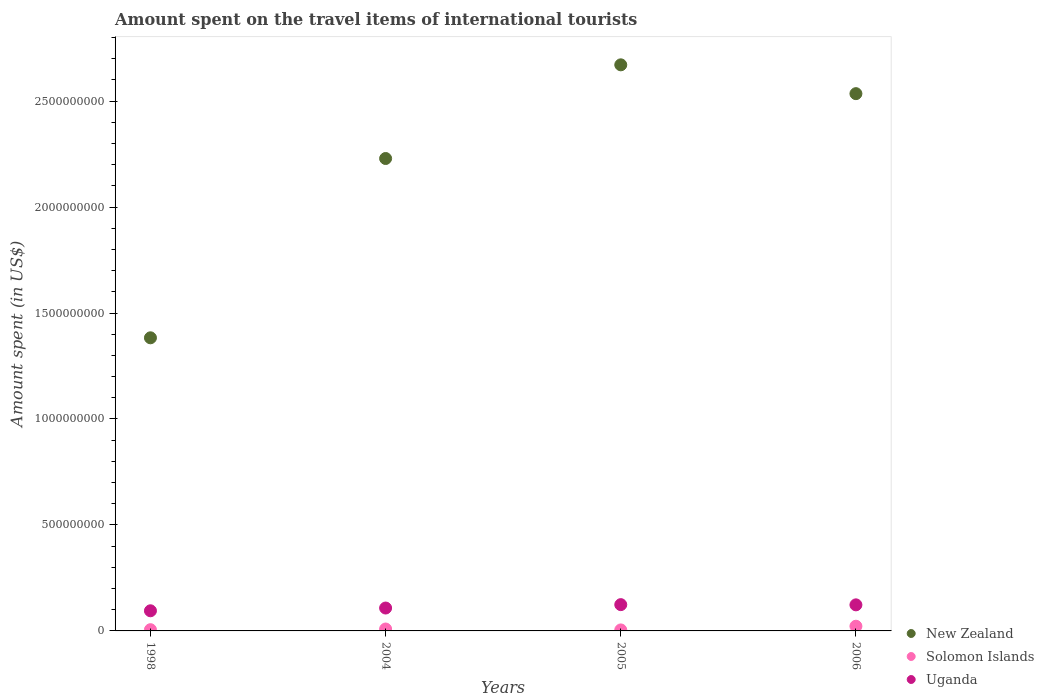How many different coloured dotlines are there?
Your answer should be very brief. 3. What is the amount spent on the travel items of international tourists in New Zealand in 2006?
Make the answer very short. 2.54e+09. Across all years, what is the maximum amount spent on the travel items of international tourists in Uganda?
Ensure brevity in your answer.  1.24e+08. Across all years, what is the minimum amount spent on the travel items of international tourists in New Zealand?
Make the answer very short. 1.38e+09. What is the total amount spent on the travel items of international tourists in Uganda in the graph?
Your answer should be compact. 4.50e+08. What is the difference between the amount spent on the travel items of international tourists in Solomon Islands in 2004 and that in 2005?
Keep it short and to the point. 4.30e+06. What is the difference between the amount spent on the travel items of international tourists in New Zealand in 1998 and the amount spent on the travel items of international tourists in Uganda in 2004?
Your response must be concise. 1.28e+09. What is the average amount spent on the travel items of international tourists in Solomon Islands per year?
Your answer should be compact. 1.04e+07. In the year 2004, what is the difference between the amount spent on the travel items of international tourists in New Zealand and amount spent on the travel items of international tourists in Uganda?
Ensure brevity in your answer.  2.12e+09. In how many years, is the amount spent on the travel items of international tourists in Uganda greater than 1100000000 US$?
Your response must be concise. 0. What is the ratio of the amount spent on the travel items of international tourists in Uganda in 2005 to that in 2006?
Your answer should be very brief. 1.01. Is the amount spent on the travel items of international tourists in New Zealand in 2004 less than that in 2006?
Make the answer very short. Yes. Is the difference between the amount spent on the travel items of international tourists in New Zealand in 2004 and 2005 greater than the difference between the amount spent on the travel items of international tourists in Uganda in 2004 and 2005?
Ensure brevity in your answer.  No. What is the difference between the highest and the second highest amount spent on the travel items of international tourists in Solomon Islands?
Provide a short and direct response. 1.32e+07. What is the difference between the highest and the lowest amount spent on the travel items of international tourists in New Zealand?
Ensure brevity in your answer.  1.29e+09. Is the sum of the amount spent on the travel items of international tourists in Solomon Islands in 1998 and 2004 greater than the maximum amount spent on the travel items of international tourists in Uganda across all years?
Keep it short and to the point. No. Is it the case that in every year, the sum of the amount spent on the travel items of international tourists in Solomon Islands and amount spent on the travel items of international tourists in Uganda  is greater than the amount spent on the travel items of international tourists in New Zealand?
Provide a short and direct response. No. Does the graph contain grids?
Give a very brief answer. No. How are the legend labels stacked?
Offer a very short reply. Vertical. What is the title of the graph?
Give a very brief answer. Amount spent on the travel items of international tourists. What is the label or title of the Y-axis?
Your answer should be very brief. Amount spent (in US$). What is the Amount spent (in US$) of New Zealand in 1998?
Provide a short and direct response. 1.38e+09. What is the Amount spent (in US$) of Solomon Islands in 1998?
Provide a short and direct response. 5.80e+06. What is the Amount spent (in US$) in Uganda in 1998?
Provide a succinct answer. 9.50e+07. What is the Amount spent (in US$) in New Zealand in 2004?
Provide a short and direct response. 2.23e+09. What is the Amount spent (in US$) in Solomon Islands in 2004?
Your answer should be compact. 9.00e+06. What is the Amount spent (in US$) in Uganda in 2004?
Keep it short and to the point. 1.08e+08. What is the Amount spent (in US$) of New Zealand in 2005?
Provide a succinct answer. 2.67e+09. What is the Amount spent (in US$) in Solomon Islands in 2005?
Make the answer very short. 4.70e+06. What is the Amount spent (in US$) in Uganda in 2005?
Your response must be concise. 1.24e+08. What is the Amount spent (in US$) of New Zealand in 2006?
Provide a succinct answer. 2.54e+09. What is the Amount spent (in US$) in Solomon Islands in 2006?
Make the answer very short. 2.22e+07. What is the Amount spent (in US$) in Uganda in 2006?
Your answer should be very brief. 1.23e+08. Across all years, what is the maximum Amount spent (in US$) of New Zealand?
Give a very brief answer. 2.67e+09. Across all years, what is the maximum Amount spent (in US$) in Solomon Islands?
Ensure brevity in your answer.  2.22e+07. Across all years, what is the maximum Amount spent (in US$) of Uganda?
Give a very brief answer. 1.24e+08. Across all years, what is the minimum Amount spent (in US$) in New Zealand?
Your answer should be compact. 1.38e+09. Across all years, what is the minimum Amount spent (in US$) in Solomon Islands?
Offer a terse response. 4.70e+06. Across all years, what is the minimum Amount spent (in US$) of Uganda?
Give a very brief answer. 9.50e+07. What is the total Amount spent (in US$) of New Zealand in the graph?
Offer a very short reply. 8.82e+09. What is the total Amount spent (in US$) of Solomon Islands in the graph?
Your answer should be very brief. 4.17e+07. What is the total Amount spent (in US$) in Uganda in the graph?
Your answer should be very brief. 4.50e+08. What is the difference between the Amount spent (in US$) in New Zealand in 1998 and that in 2004?
Ensure brevity in your answer.  -8.46e+08. What is the difference between the Amount spent (in US$) in Solomon Islands in 1998 and that in 2004?
Provide a succinct answer. -3.20e+06. What is the difference between the Amount spent (in US$) in Uganda in 1998 and that in 2004?
Offer a terse response. -1.30e+07. What is the difference between the Amount spent (in US$) in New Zealand in 1998 and that in 2005?
Provide a short and direct response. -1.29e+09. What is the difference between the Amount spent (in US$) in Solomon Islands in 1998 and that in 2005?
Your response must be concise. 1.10e+06. What is the difference between the Amount spent (in US$) of Uganda in 1998 and that in 2005?
Ensure brevity in your answer.  -2.90e+07. What is the difference between the Amount spent (in US$) of New Zealand in 1998 and that in 2006?
Keep it short and to the point. -1.15e+09. What is the difference between the Amount spent (in US$) in Solomon Islands in 1998 and that in 2006?
Give a very brief answer. -1.64e+07. What is the difference between the Amount spent (in US$) of Uganda in 1998 and that in 2006?
Offer a terse response. -2.80e+07. What is the difference between the Amount spent (in US$) of New Zealand in 2004 and that in 2005?
Your response must be concise. -4.42e+08. What is the difference between the Amount spent (in US$) in Solomon Islands in 2004 and that in 2005?
Provide a short and direct response. 4.30e+06. What is the difference between the Amount spent (in US$) of Uganda in 2004 and that in 2005?
Make the answer very short. -1.60e+07. What is the difference between the Amount spent (in US$) in New Zealand in 2004 and that in 2006?
Your response must be concise. -3.06e+08. What is the difference between the Amount spent (in US$) of Solomon Islands in 2004 and that in 2006?
Your response must be concise. -1.32e+07. What is the difference between the Amount spent (in US$) in Uganda in 2004 and that in 2006?
Provide a short and direct response. -1.50e+07. What is the difference between the Amount spent (in US$) of New Zealand in 2005 and that in 2006?
Your answer should be very brief. 1.36e+08. What is the difference between the Amount spent (in US$) in Solomon Islands in 2005 and that in 2006?
Ensure brevity in your answer.  -1.75e+07. What is the difference between the Amount spent (in US$) of New Zealand in 1998 and the Amount spent (in US$) of Solomon Islands in 2004?
Your answer should be very brief. 1.37e+09. What is the difference between the Amount spent (in US$) of New Zealand in 1998 and the Amount spent (in US$) of Uganda in 2004?
Provide a succinct answer. 1.28e+09. What is the difference between the Amount spent (in US$) in Solomon Islands in 1998 and the Amount spent (in US$) in Uganda in 2004?
Provide a short and direct response. -1.02e+08. What is the difference between the Amount spent (in US$) of New Zealand in 1998 and the Amount spent (in US$) of Solomon Islands in 2005?
Your answer should be compact. 1.38e+09. What is the difference between the Amount spent (in US$) of New Zealand in 1998 and the Amount spent (in US$) of Uganda in 2005?
Your answer should be very brief. 1.26e+09. What is the difference between the Amount spent (in US$) in Solomon Islands in 1998 and the Amount spent (in US$) in Uganda in 2005?
Keep it short and to the point. -1.18e+08. What is the difference between the Amount spent (in US$) in New Zealand in 1998 and the Amount spent (in US$) in Solomon Islands in 2006?
Your answer should be very brief. 1.36e+09. What is the difference between the Amount spent (in US$) in New Zealand in 1998 and the Amount spent (in US$) in Uganda in 2006?
Offer a very short reply. 1.26e+09. What is the difference between the Amount spent (in US$) in Solomon Islands in 1998 and the Amount spent (in US$) in Uganda in 2006?
Keep it short and to the point. -1.17e+08. What is the difference between the Amount spent (in US$) of New Zealand in 2004 and the Amount spent (in US$) of Solomon Islands in 2005?
Keep it short and to the point. 2.22e+09. What is the difference between the Amount spent (in US$) of New Zealand in 2004 and the Amount spent (in US$) of Uganda in 2005?
Make the answer very short. 2.10e+09. What is the difference between the Amount spent (in US$) in Solomon Islands in 2004 and the Amount spent (in US$) in Uganda in 2005?
Offer a very short reply. -1.15e+08. What is the difference between the Amount spent (in US$) in New Zealand in 2004 and the Amount spent (in US$) in Solomon Islands in 2006?
Make the answer very short. 2.21e+09. What is the difference between the Amount spent (in US$) of New Zealand in 2004 and the Amount spent (in US$) of Uganda in 2006?
Provide a short and direct response. 2.11e+09. What is the difference between the Amount spent (in US$) in Solomon Islands in 2004 and the Amount spent (in US$) in Uganda in 2006?
Your answer should be very brief. -1.14e+08. What is the difference between the Amount spent (in US$) in New Zealand in 2005 and the Amount spent (in US$) in Solomon Islands in 2006?
Keep it short and to the point. 2.65e+09. What is the difference between the Amount spent (in US$) of New Zealand in 2005 and the Amount spent (in US$) of Uganda in 2006?
Provide a succinct answer. 2.55e+09. What is the difference between the Amount spent (in US$) of Solomon Islands in 2005 and the Amount spent (in US$) of Uganda in 2006?
Offer a very short reply. -1.18e+08. What is the average Amount spent (in US$) in New Zealand per year?
Your answer should be compact. 2.20e+09. What is the average Amount spent (in US$) of Solomon Islands per year?
Your answer should be compact. 1.04e+07. What is the average Amount spent (in US$) in Uganda per year?
Offer a very short reply. 1.12e+08. In the year 1998, what is the difference between the Amount spent (in US$) in New Zealand and Amount spent (in US$) in Solomon Islands?
Your answer should be compact. 1.38e+09. In the year 1998, what is the difference between the Amount spent (in US$) in New Zealand and Amount spent (in US$) in Uganda?
Provide a short and direct response. 1.29e+09. In the year 1998, what is the difference between the Amount spent (in US$) in Solomon Islands and Amount spent (in US$) in Uganda?
Your answer should be very brief. -8.92e+07. In the year 2004, what is the difference between the Amount spent (in US$) of New Zealand and Amount spent (in US$) of Solomon Islands?
Give a very brief answer. 2.22e+09. In the year 2004, what is the difference between the Amount spent (in US$) of New Zealand and Amount spent (in US$) of Uganda?
Give a very brief answer. 2.12e+09. In the year 2004, what is the difference between the Amount spent (in US$) in Solomon Islands and Amount spent (in US$) in Uganda?
Your response must be concise. -9.90e+07. In the year 2005, what is the difference between the Amount spent (in US$) of New Zealand and Amount spent (in US$) of Solomon Islands?
Make the answer very short. 2.67e+09. In the year 2005, what is the difference between the Amount spent (in US$) of New Zealand and Amount spent (in US$) of Uganda?
Keep it short and to the point. 2.55e+09. In the year 2005, what is the difference between the Amount spent (in US$) of Solomon Islands and Amount spent (in US$) of Uganda?
Keep it short and to the point. -1.19e+08. In the year 2006, what is the difference between the Amount spent (in US$) of New Zealand and Amount spent (in US$) of Solomon Islands?
Your answer should be compact. 2.51e+09. In the year 2006, what is the difference between the Amount spent (in US$) of New Zealand and Amount spent (in US$) of Uganda?
Offer a very short reply. 2.41e+09. In the year 2006, what is the difference between the Amount spent (in US$) of Solomon Islands and Amount spent (in US$) of Uganda?
Offer a terse response. -1.01e+08. What is the ratio of the Amount spent (in US$) in New Zealand in 1998 to that in 2004?
Provide a succinct answer. 0.62. What is the ratio of the Amount spent (in US$) of Solomon Islands in 1998 to that in 2004?
Provide a short and direct response. 0.64. What is the ratio of the Amount spent (in US$) of Uganda in 1998 to that in 2004?
Offer a terse response. 0.88. What is the ratio of the Amount spent (in US$) in New Zealand in 1998 to that in 2005?
Offer a terse response. 0.52. What is the ratio of the Amount spent (in US$) of Solomon Islands in 1998 to that in 2005?
Offer a terse response. 1.23. What is the ratio of the Amount spent (in US$) of Uganda in 1998 to that in 2005?
Keep it short and to the point. 0.77. What is the ratio of the Amount spent (in US$) of New Zealand in 1998 to that in 2006?
Offer a very short reply. 0.55. What is the ratio of the Amount spent (in US$) in Solomon Islands in 1998 to that in 2006?
Ensure brevity in your answer.  0.26. What is the ratio of the Amount spent (in US$) in Uganda in 1998 to that in 2006?
Your answer should be compact. 0.77. What is the ratio of the Amount spent (in US$) of New Zealand in 2004 to that in 2005?
Your answer should be very brief. 0.83. What is the ratio of the Amount spent (in US$) in Solomon Islands in 2004 to that in 2005?
Your answer should be very brief. 1.91. What is the ratio of the Amount spent (in US$) of Uganda in 2004 to that in 2005?
Your answer should be very brief. 0.87. What is the ratio of the Amount spent (in US$) in New Zealand in 2004 to that in 2006?
Your answer should be compact. 0.88. What is the ratio of the Amount spent (in US$) of Solomon Islands in 2004 to that in 2006?
Offer a very short reply. 0.41. What is the ratio of the Amount spent (in US$) of Uganda in 2004 to that in 2006?
Your response must be concise. 0.88. What is the ratio of the Amount spent (in US$) in New Zealand in 2005 to that in 2006?
Make the answer very short. 1.05. What is the ratio of the Amount spent (in US$) in Solomon Islands in 2005 to that in 2006?
Make the answer very short. 0.21. What is the ratio of the Amount spent (in US$) in Uganda in 2005 to that in 2006?
Give a very brief answer. 1.01. What is the difference between the highest and the second highest Amount spent (in US$) in New Zealand?
Ensure brevity in your answer.  1.36e+08. What is the difference between the highest and the second highest Amount spent (in US$) in Solomon Islands?
Ensure brevity in your answer.  1.32e+07. What is the difference between the highest and the lowest Amount spent (in US$) of New Zealand?
Your response must be concise. 1.29e+09. What is the difference between the highest and the lowest Amount spent (in US$) of Solomon Islands?
Provide a short and direct response. 1.75e+07. What is the difference between the highest and the lowest Amount spent (in US$) of Uganda?
Give a very brief answer. 2.90e+07. 